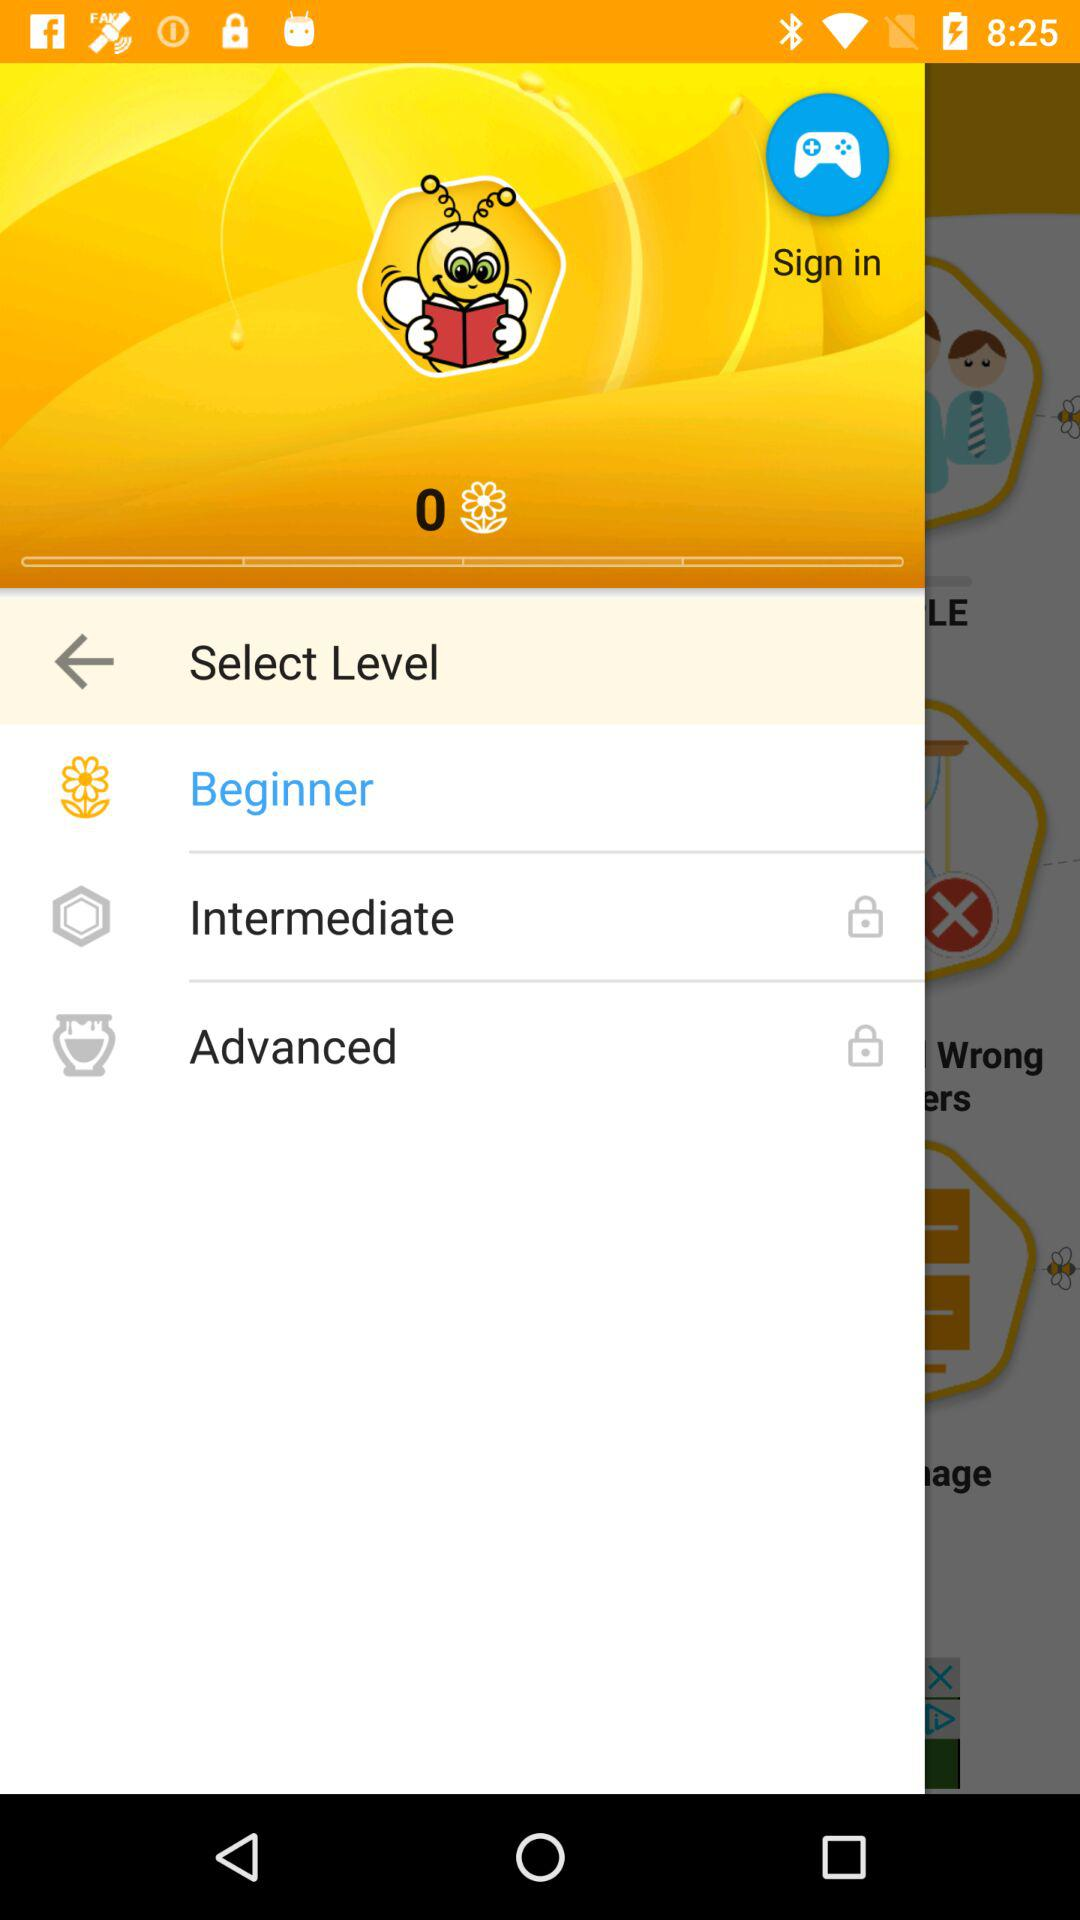How many levels are there?
Answer the question using a single word or phrase. 3 